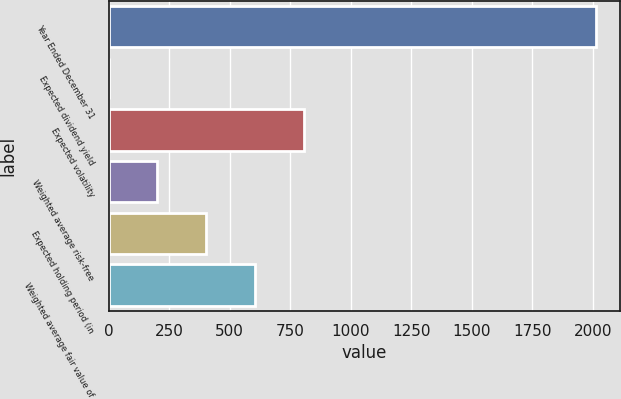Convert chart to OTSL. <chart><loc_0><loc_0><loc_500><loc_500><bar_chart><fcel>Year Ended December 31<fcel>Expected dividend yield<fcel>Expected volatility<fcel>Weighted average risk-free<fcel>Expected holding period (in<fcel>Weighted average fair value of<nl><fcel>2012<fcel>0.6<fcel>805.16<fcel>201.74<fcel>402.88<fcel>604.02<nl></chart> 